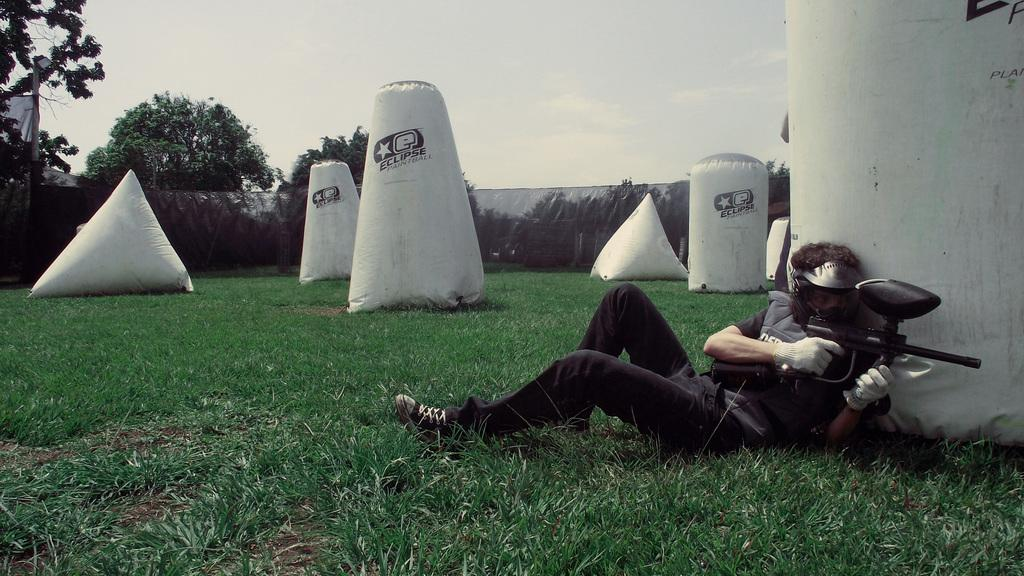What is the main subject of the image? There is a person in the image. What is the person holding in their hand? The person is holding a gun in their hand. Where is the person located in the image? The person is lying on the grass. What can be seen in the background of the image? There are pillars, a fence, trees, and the sky visible in the background of the image. Can you describe the time of day when the image was taken? The image was taken during the day. How many cobwebs can be seen in the image? There are no cobwebs present in the image. What is the person's desire in the image? The image does not provide information about the person's desires, so it cannot be determined. 